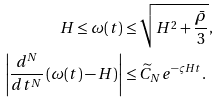Convert formula to latex. <formula><loc_0><loc_0><loc_500><loc_500>H \leq \omega ( t ) & \leq \sqrt { H ^ { 2 } + \frac { \bar { \rho } } { 3 } } , \\ \left | \frac { d ^ { N } } { d t ^ { N } } \left ( \omega ( t ) - H \right ) \right | & \leq \widetilde { C } _ { N } e ^ { - \varsigma H t } .</formula> 